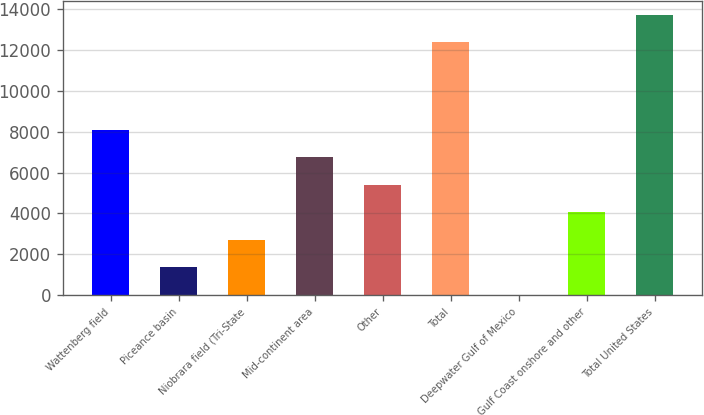Convert chart to OTSL. <chart><loc_0><loc_0><loc_500><loc_500><bar_chart><fcel>Wattenberg field<fcel>Piceance basin<fcel>Niobrara field (Tri-State<fcel>Mid-continent area<fcel>Other<fcel>Total<fcel>Deepwater Gulf of Mexico<fcel>Gulf Coast onshore and other<fcel>Total United States<nl><fcel>8097<fcel>1359.5<fcel>2707<fcel>6749.5<fcel>5402<fcel>12402<fcel>12<fcel>4054.5<fcel>13749.5<nl></chart> 